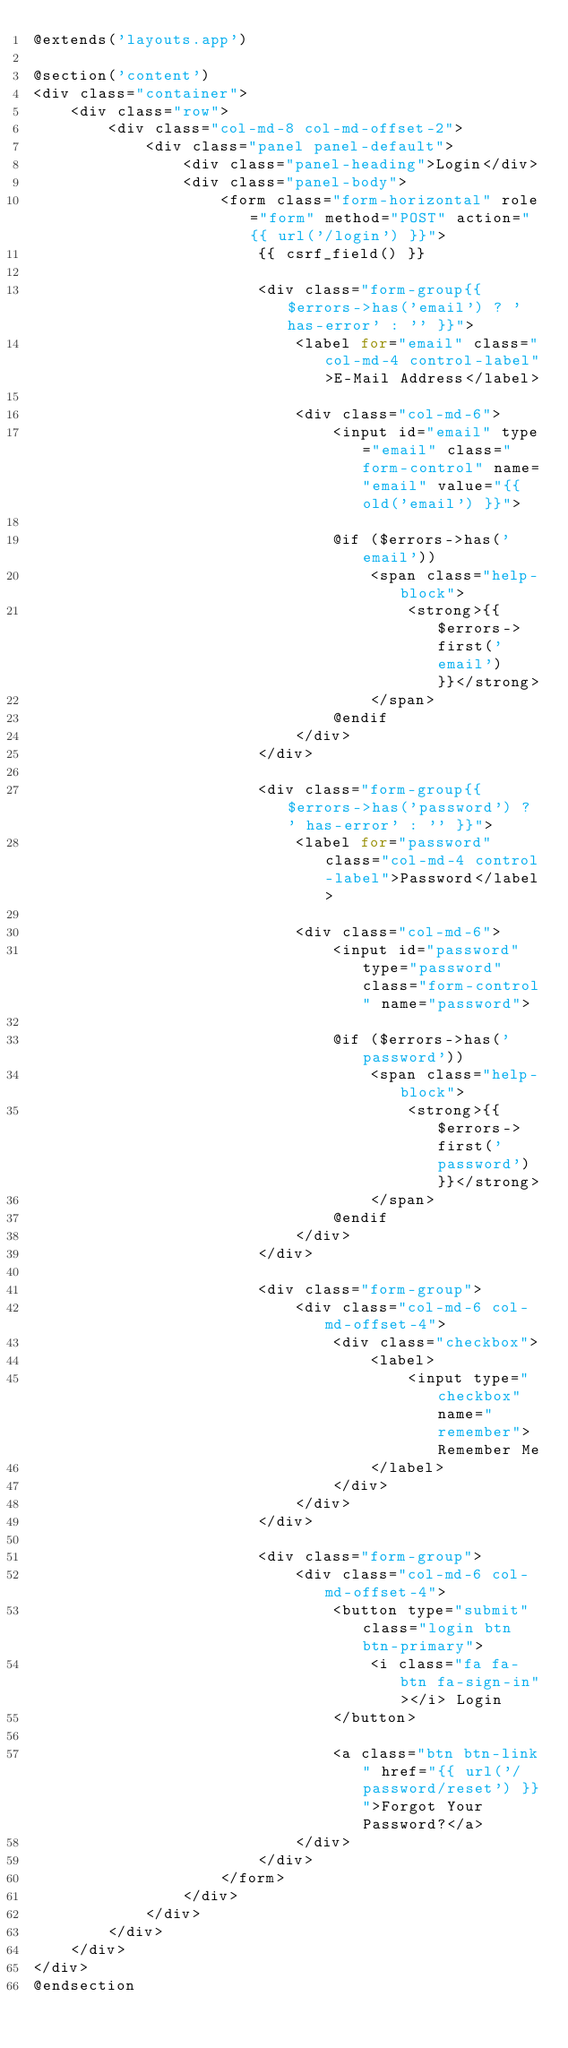Convert code to text. <code><loc_0><loc_0><loc_500><loc_500><_PHP_>@extends('layouts.app')

@section('content')
<div class="container">
    <div class="row">
        <div class="col-md-8 col-md-offset-2">
            <div class="panel panel-default">
                <div class="panel-heading">Login</div>
                <div class="panel-body">
                    <form class="form-horizontal" role="form" method="POST" action="{{ url('/login') }}">
                        {{ csrf_field() }}

                        <div class="form-group{{ $errors->has('email') ? ' has-error' : '' }}">
                            <label for="email" class="col-md-4 control-label">E-Mail Address</label>

                            <div class="col-md-6">
                                <input id="email" type="email" class="form-control" name="email" value="{{ old('email') }}">

                                @if ($errors->has('email'))
                                    <span class="help-block">
                                        <strong>{{ $errors->first('email') }}</strong>
                                    </span>
                                @endif
                            </div>
                        </div>

                        <div class="form-group{{ $errors->has('password') ? ' has-error' : '' }}">
                            <label for="password" class="col-md-4 control-label">Password</label>

                            <div class="col-md-6">
                                <input id="password" type="password" class="form-control" name="password">

                                @if ($errors->has('password'))
                                    <span class="help-block">
                                        <strong>{{ $errors->first('password') }}</strong>
                                    </span>
                                @endif
                            </div>
                        </div>

                        <div class="form-group">
                            <div class="col-md-6 col-md-offset-4">
                                <div class="checkbox">
                                    <label>
                                        <input type="checkbox" name="remember"> Remember Me
                                    </label>
                                </div>
                            </div>
                        </div>

                        <div class="form-group">
                            <div class="col-md-6 col-md-offset-4">
                                <button type="submit" class="login btn btn-primary">
                                    <i class="fa fa-btn fa-sign-in"></i> Login
                                </button>

                                <a class="btn btn-link" href="{{ url('/password/reset') }}">Forgot Your Password?</a>
                            </div>
                        </div>
                    </form>
                </div>
            </div>
        </div>
    </div>
</div>
@endsection
</code> 